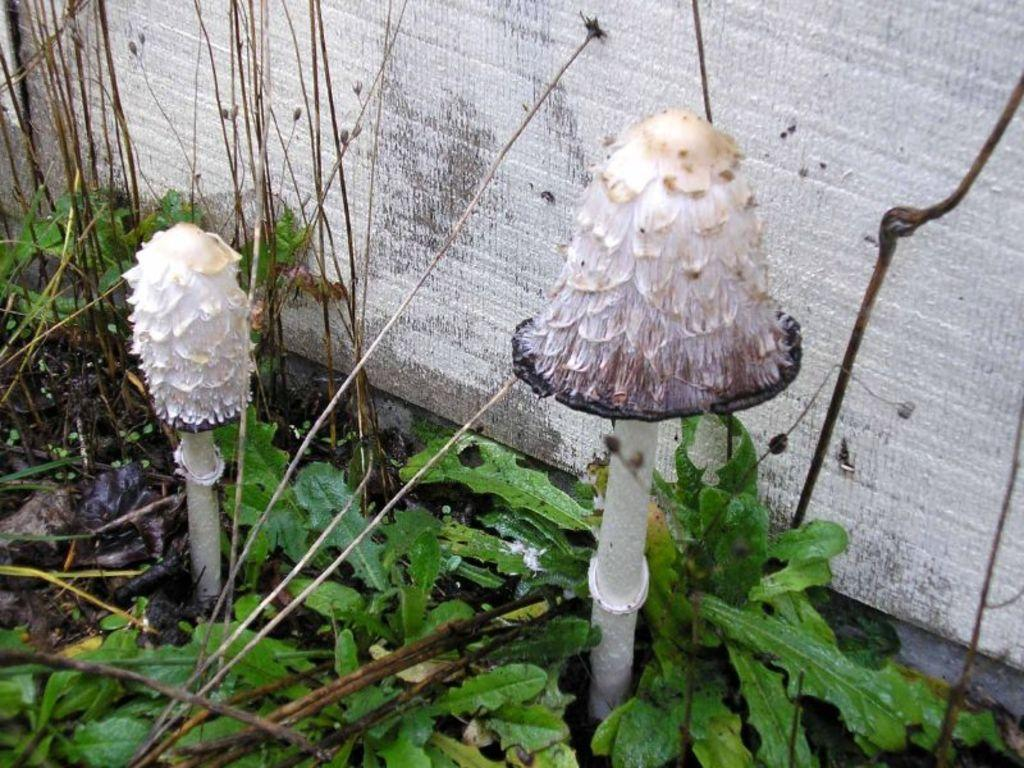What is located in the center of the image? There are mushrooms and plants in the center of the image. Can you describe the plants in the image? The plants in the image are not specified, but they are located in the center along with the mushrooms. What is visible in the background of the image? There is a wall in the background of the image. What type of arm is visible in the image? There is no arm present in the image. Can you describe the woman in the image? There is no woman present in the image. 